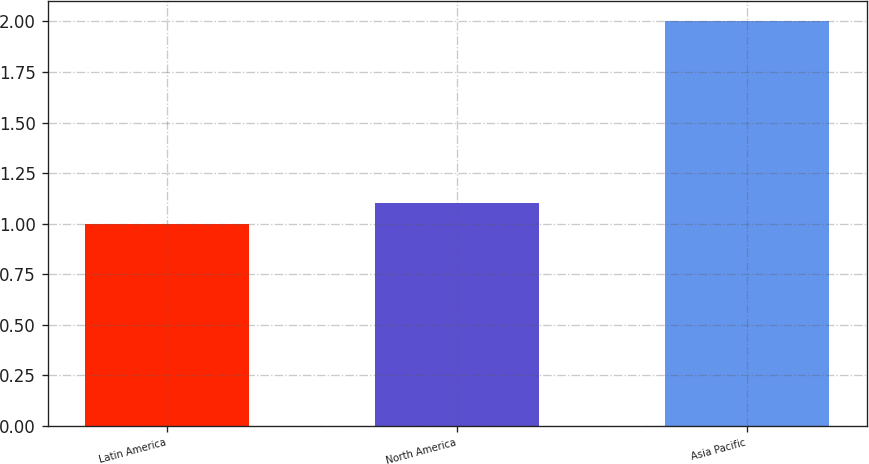Convert chart. <chart><loc_0><loc_0><loc_500><loc_500><bar_chart><fcel>Latin America<fcel>North America<fcel>Asia Pacific<nl><fcel>1<fcel>1.1<fcel>2<nl></chart> 